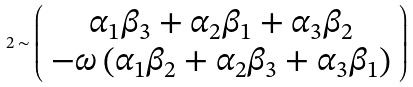<formula> <loc_0><loc_0><loc_500><loc_500>2 \sim \left ( \begin{array} { c } \alpha _ { 1 } \beta _ { 3 } + \alpha _ { 2 } \beta _ { 1 } + \alpha _ { 3 } \beta _ { 2 } \\ - \omega \left ( \alpha _ { 1 } \beta _ { 2 } + \alpha _ { 2 } \beta _ { 3 } + \alpha _ { 3 } \beta _ { 1 } \right ) \end{array} \right )</formula> 